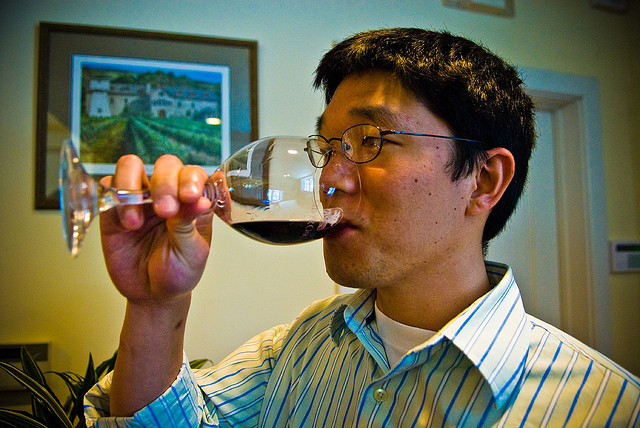<image>What animal does the drink depict? I am not sure what animal the drink depicts. It can be a vulture, human, cat, tiger, or none. What animal does the drink depict? I don't know what animal the drink depicts. It can be seen as a vulture, a human, a cat, or a tiger. 